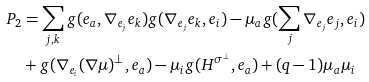<formula> <loc_0><loc_0><loc_500><loc_500>P _ { 2 } & = \sum _ { j , k } g ( e _ { a } , \nabla _ { e _ { j } } e _ { k } ) g ( \nabla _ { e _ { j } } e _ { k } , e _ { i } ) - \mu _ { a } g ( \sum _ { j } \nabla _ { e _ { j } } e _ { j } , e _ { i } ) \\ & + g ( \nabla _ { e _ { i } } ( \nabla \mu ) ^ { \bot } , e _ { a } ) - \mu _ { i } g ( H ^ { \sigma ^ { \bot } } , e _ { a } ) + ( q - 1 ) \mu _ { a } \mu _ { i }</formula> 